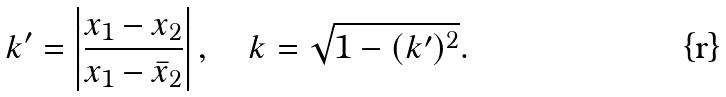Convert formula to latex. <formula><loc_0><loc_0><loc_500><loc_500>k ^ { \prime } = \left | \frac { x _ { 1 } - x _ { 2 } } { x _ { 1 } - \bar { x } _ { 2 } } \right | , \quad k = \sqrt { 1 - ( k ^ { \prime } ) ^ { 2 } } .</formula> 